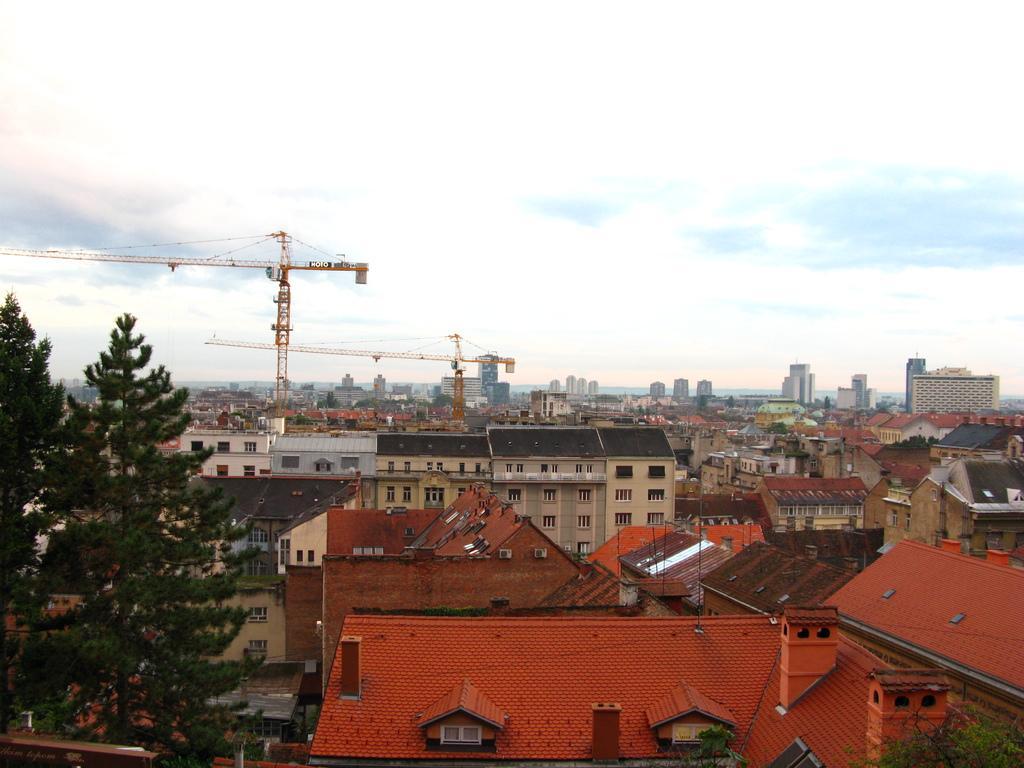Please provide a concise description of this image. Here we can see houses,buildings,roofs,windows,poles and trees on the left side. In the background there are buildings,trees,poles,windows,cranes and clouds in the sky. 